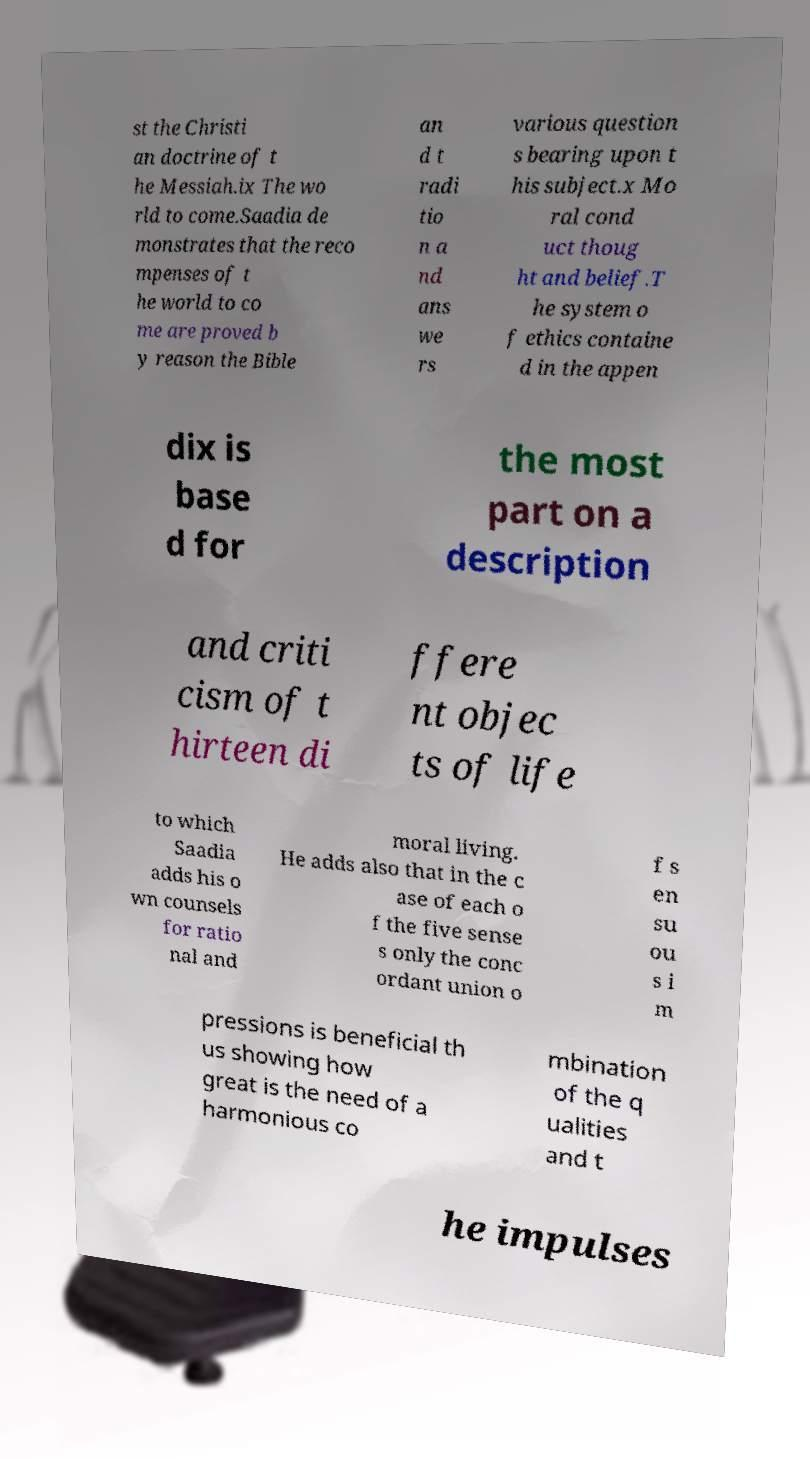For documentation purposes, I need the text within this image transcribed. Could you provide that? st the Christi an doctrine of t he Messiah.ix The wo rld to come.Saadia de monstrates that the reco mpenses of t he world to co me are proved b y reason the Bible an d t radi tio n a nd ans we rs various question s bearing upon t his subject.x Mo ral cond uct thoug ht and belief.T he system o f ethics containe d in the appen dix is base d for the most part on a description and criti cism of t hirteen di ffere nt objec ts of life to which Saadia adds his o wn counsels for ratio nal and moral living. He adds also that in the c ase of each o f the five sense s only the conc ordant union o f s en su ou s i m pressions is beneficial th us showing how great is the need of a harmonious co mbination of the q ualities and t he impulses 